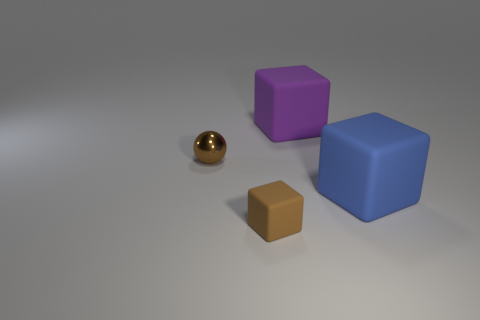Do the matte object that is behind the metallic object and the ball have the same color?
Offer a terse response. No. Is there a large purple cube made of the same material as the tiny brown sphere?
Offer a very short reply. No. What is the shape of the tiny shiny thing that is the same color as the small block?
Offer a terse response. Sphere. Is the number of large matte cubes to the right of the big blue matte object less than the number of large cubes?
Your response must be concise. Yes. Does the purple rubber cube behind the blue object have the same size as the big blue thing?
Your answer should be compact. Yes. What number of other brown things have the same shape as the small brown rubber object?
Ensure brevity in your answer.  0. What is the size of the purple cube that is made of the same material as the blue cube?
Offer a terse response. Large. Are there an equal number of tiny brown metal spheres right of the small cube and brown shiny balls?
Keep it short and to the point. No. Does the small metallic ball have the same color as the small rubber object?
Keep it short and to the point. Yes. Does the brown object in front of the shiny thing have the same shape as the large thing behind the blue matte block?
Offer a terse response. Yes. 